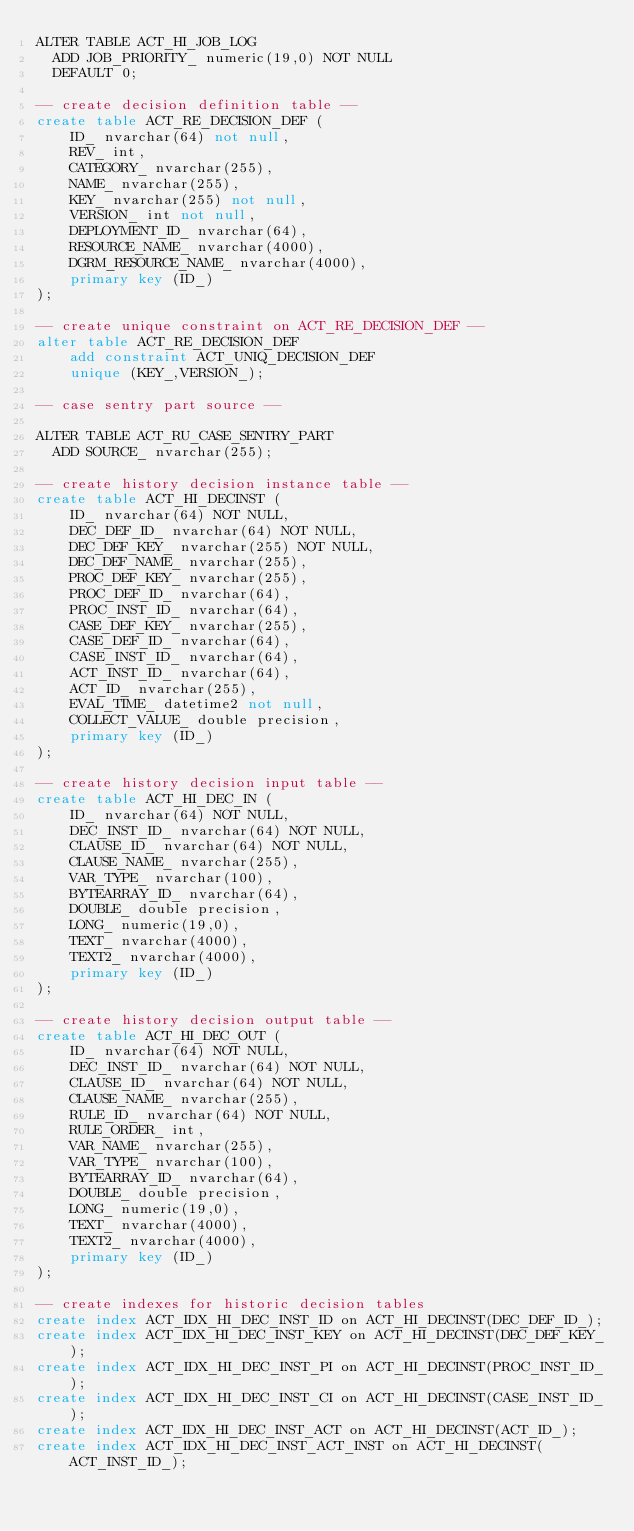<code> <loc_0><loc_0><loc_500><loc_500><_SQL_>ALTER TABLE ACT_HI_JOB_LOG
  ADD JOB_PRIORITY_ numeric(19,0) NOT NULL
  DEFAULT 0;

-- create decision definition table --
create table ACT_RE_DECISION_DEF (
    ID_ nvarchar(64) not null,
    REV_ int,
    CATEGORY_ nvarchar(255),
    NAME_ nvarchar(255),
    KEY_ nvarchar(255) not null,
    VERSION_ int not null,
    DEPLOYMENT_ID_ nvarchar(64),
    RESOURCE_NAME_ nvarchar(4000),
    DGRM_RESOURCE_NAME_ nvarchar(4000),
    primary key (ID_)
);

-- create unique constraint on ACT_RE_DECISION_DEF --
alter table ACT_RE_DECISION_DEF
    add constraint ACT_UNIQ_DECISION_DEF
    unique (KEY_,VERSION_);

-- case sentry part source --

ALTER TABLE ACT_RU_CASE_SENTRY_PART
  ADD SOURCE_ nvarchar(255);

-- create history decision instance table --
create table ACT_HI_DECINST (
    ID_ nvarchar(64) NOT NULL,
    DEC_DEF_ID_ nvarchar(64) NOT NULL,
    DEC_DEF_KEY_ nvarchar(255) NOT NULL,
    DEC_DEF_NAME_ nvarchar(255),
    PROC_DEF_KEY_ nvarchar(255),
    PROC_DEF_ID_ nvarchar(64),
    PROC_INST_ID_ nvarchar(64),
    CASE_DEF_KEY_ nvarchar(255),
    CASE_DEF_ID_ nvarchar(64),
    CASE_INST_ID_ nvarchar(64),
    ACT_INST_ID_ nvarchar(64),
    ACT_ID_ nvarchar(255),
    EVAL_TIME_ datetime2 not null,
    COLLECT_VALUE_ double precision,
    primary key (ID_)
);

-- create history decision input table --
create table ACT_HI_DEC_IN (
    ID_ nvarchar(64) NOT NULL,
    DEC_INST_ID_ nvarchar(64) NOT NULL,
    CLAUSE_ID_ nvarchar(64) NOT NULL,
    CLAUSE_NAME_ nvarchar(255),
    VAR_TYPE_ nvarchar(100),
    BYTEARRAY_ID_ nvarchar(64),
    DOUBLE_ double precision,
    LONG_ numeric(19,0),
    TEXT_ nvarchar(4000),
    TEXT2_ nvarchar(4000),
    primary key (ID_)
);

-- create history decision output table --
create table ACT_HI_DEC_OUT (
    ID_ nvarchar(64) NOT NULL,
    DEC_INST_ID_ nvarchar(64) NOT NULL,
    CLAUSE_ID_ nvarchar(64) NOT NULL,
    CLAUSE_NAME_ nvarchar(255),
    RULE_ID_ nvarchar(64) NOT NULL,
    RULE_ORDER_ int,
    VAR_NAME_ nvarchar(255),
    VAR_TYPE_ nvarchar(100),
    BYTEARRAY_ID_ nvarchar(64),
    DOUBLE_ double precision,
    LONG_ numeric(19,0),
    TEXT_ nvarchar(4000),
    TEXT2_ nvarchar(4000),
    primary key (ID_)
);

-- create indexes for historic decision tables
create index ACT_IDX_HI_DEC_INST_ID on ACT_HI_DECINST(DEC_DEF_ID_);
create index ACT_IDX_HI_DEC_INST_KEY on ACT_HI_DECINST(DEC_DEF_KEY_);
create index ACT_IDX_HI_DEC_INST_PI on ACT_HI_DECINST(PROC_INST_ID_);
create index ACT_IDX_HI_DEC_INST_CI on ACT_HI_DECINST(CASE_INST_ID_);
create index ACT_IDX_HI_DEC_INST_ACT on ACT_HI_DECINST(ACT_ID_);
create index ACT_IDX_HI_DEC_INST_ACT_INST on ACT_HI_DECINST(ACT_INST_ID_);</code> 